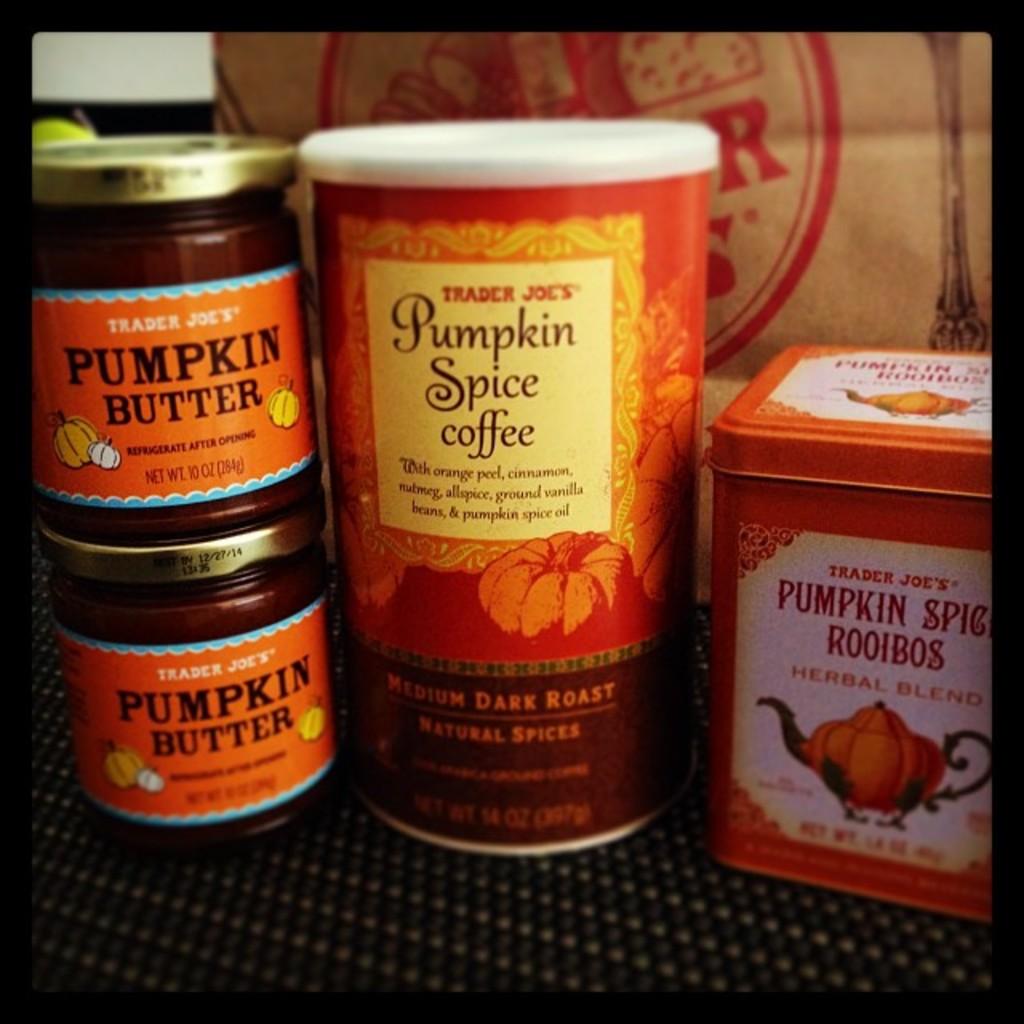What shop has pumpkin butter?
Your answer should be very brief. Trader joes. What is in the middle container?
Offer a very short reply. Pumpkin spice coffee. 